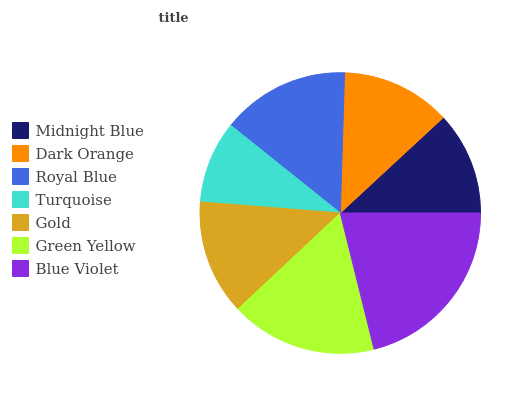Is Turquoise the minimum?
Answer yes or no. Yes. Is Blue Violet the maximum?
Answer yes or no. Yes. Is Dark Orange the minimum?
Answer yes or no. No. Is Dark Orange the maximum?
Answer yes or no. No. Is Dark Orange greater than Midnight Blue?
Answer yes or no. Yes. Is Midnight Blue less than Dark Orange?
Answer yes or no. Yes. Is Midnight Blue greater than Dark Orange?
Answer yes or no. No. Is Dark Orange less than Midnight Blue?
Answer yes or no. No. Is Gold the high median?
Answer yes or no. Yes. Is Gold the low median?
Answer yes or no. Yes. Is Royal Blue the high median?
Answer yes or no. No. Is Green Yellow the low median?
Answer yes or no. No. 